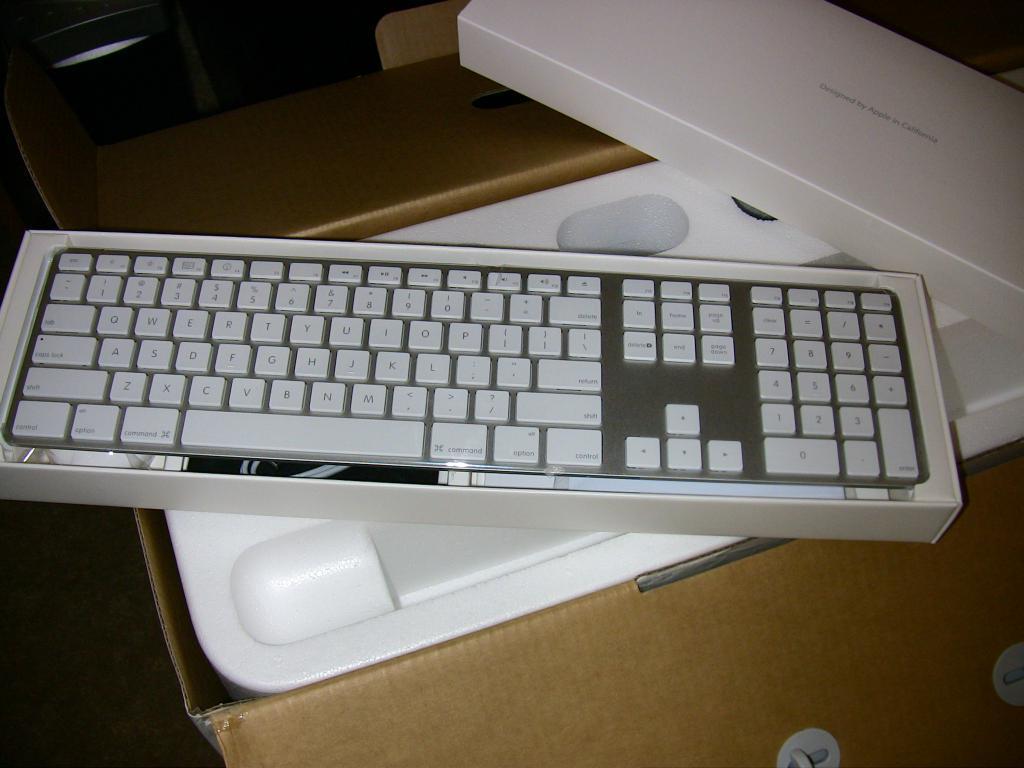Describe this image in one or two sentences. In this picture we can see a box, on box we can see a keyboard. On the left side, the image is dark. 